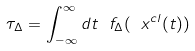<formula> <loc_0><loc_0><loc_500><loc_500>\tau _ { \Delta } = \int _ { - \infty } ^ { \infty } d t \ f _ { \Delta } ( \ x ^ { c l } ( t ) )</formula> 